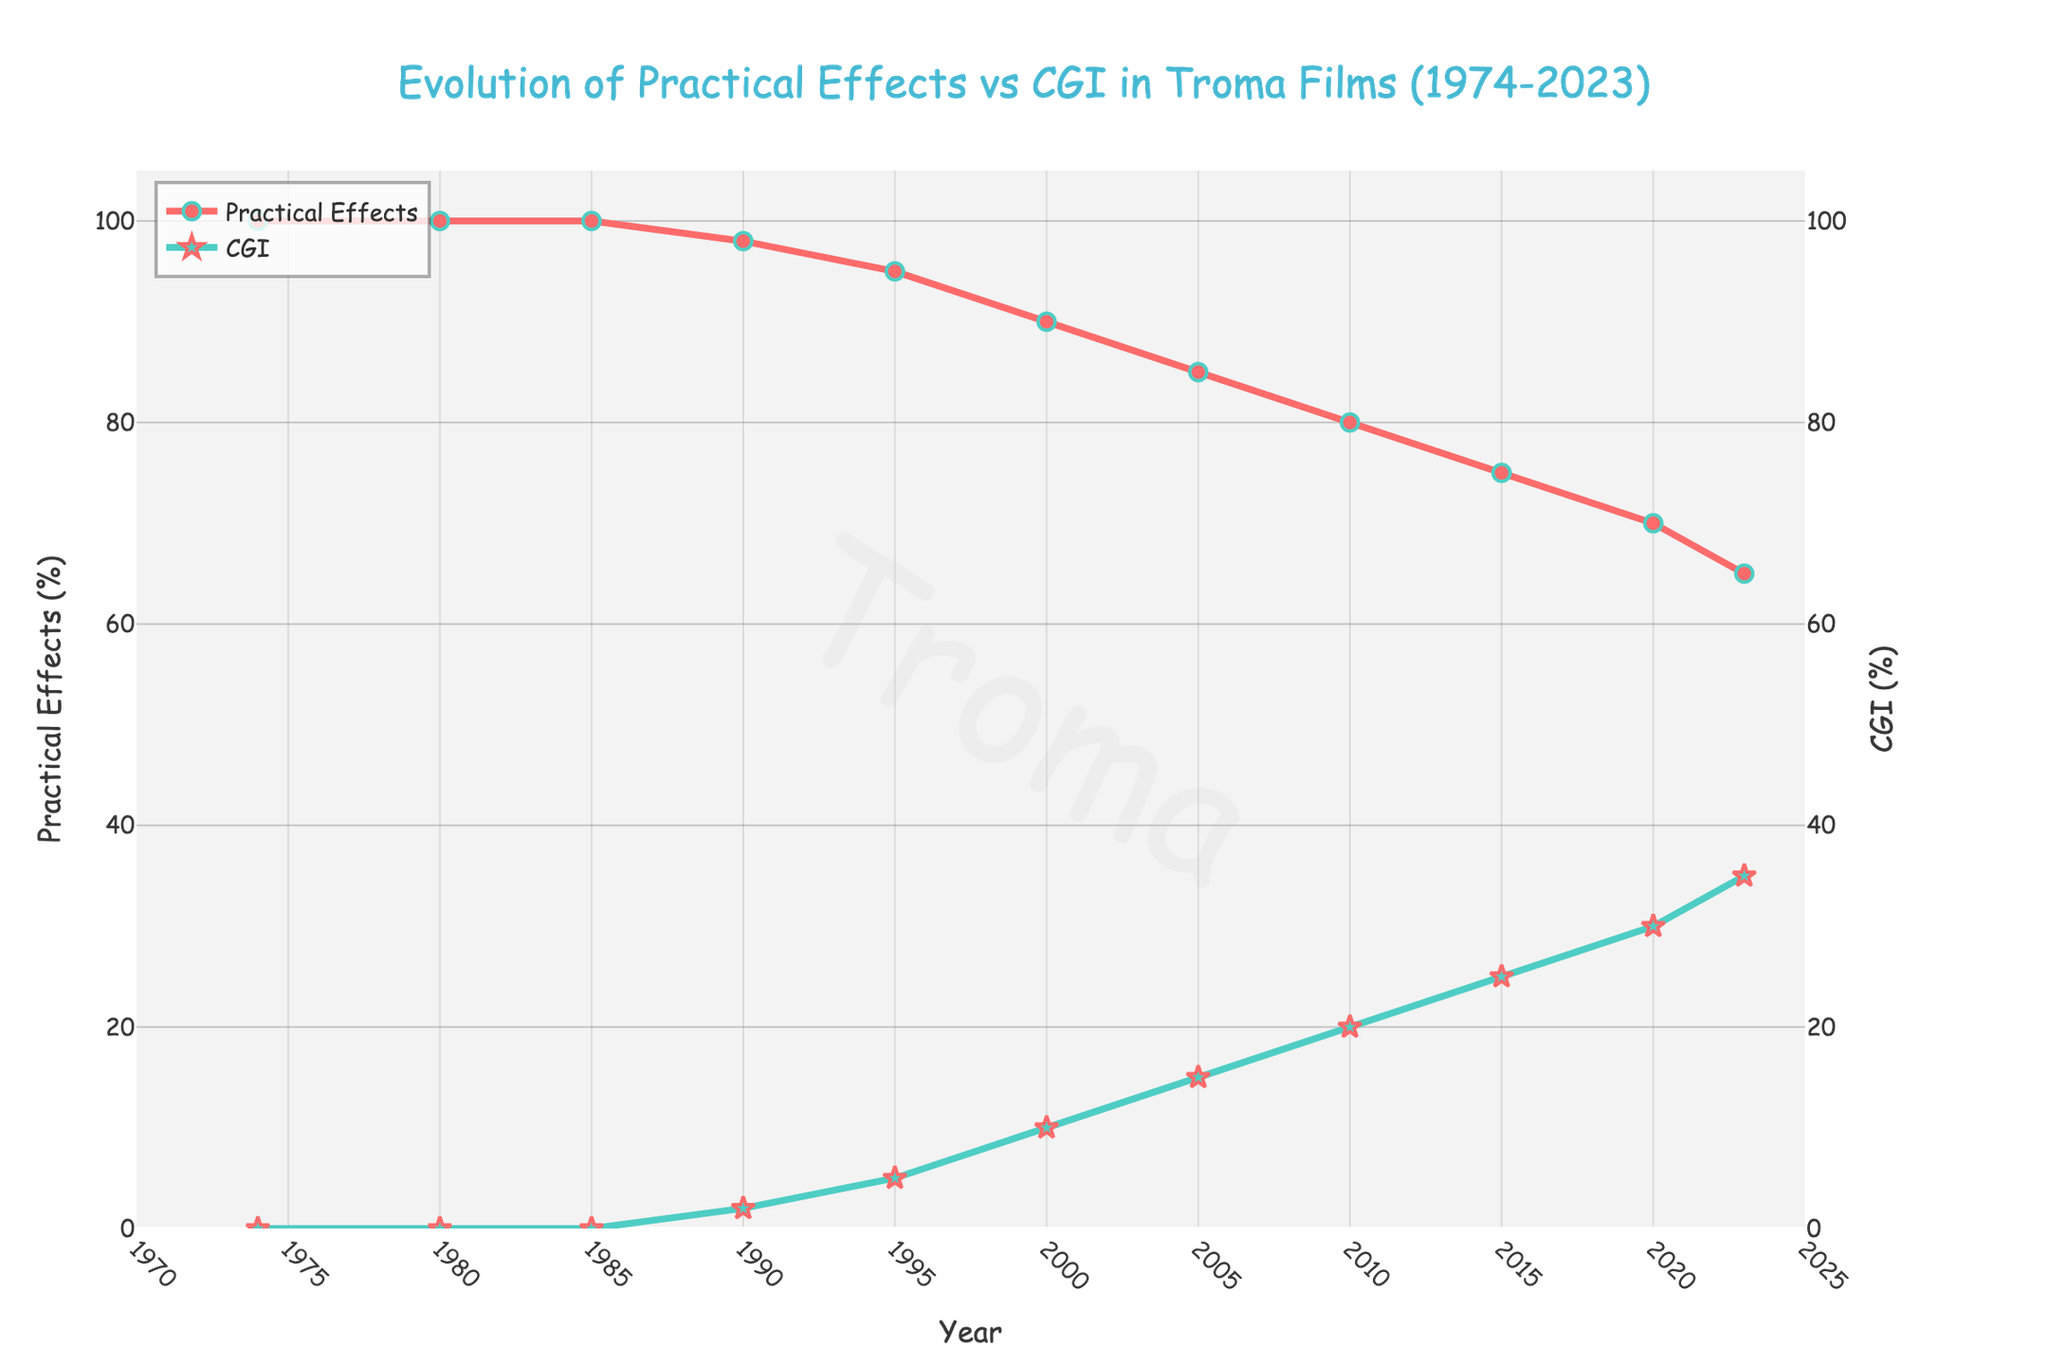What's the overall trend in the usage of practical effects from 1974 to 2023? By examining the line representing practical effects, you can see it starts at 100% in 1974 and gradually declines to 65% by 2023. The overall trend is a decrease in the usage of practical effects over time.
Answer: Decreasing In which year did the usage of CGI first appear in Troma films according to the chart? The CGI percentage is zero until 1990, where it first shows a value of 2%. Therefore, CGI usage first appears in 1990 according to the chart.
Answer: 1990 What is the difference in practical effects usage between 1980 and 2023? Practical effects in 1980 were at 100%. In 2023, they were at 65%. The difference in usage is 100% - 65% = 35%.
Answer: 35% By how much did the CGI usage increase from 2000 to 2023? In 2000, CGI usage is at 10%. By 2023, it increased to 35%. The increase in percentage is 35% - 10% = 25%.
Answer: 25% Compare the rates of change in practical effects and CGI between 2010 and 2020. Between 2010 and 2020, practical effects decreased from 80% to 70%, a change of 10%. CGI increased from 20% to 30%, also a change of 10%.
Answer: Same What is the percentage of practical effects compared to CGI in 2015? In 2015, practical effects are at 75%, and CGI is at 25%.
Answer: 75% vs 25% At what point did the difference between practical effects and CGI usage first equal 50%? In 2010, practical effects are at 80% and CGI is at 20%, so the difference is 80% - 20% = 60%. By 2015, practical effects are at 75% and CGI is at 25%, so the difference is 75% - 25% = 50%. Thus, this occurs in 2015.
Answer: 2015 What is the average percentage of practical effects from 1974 to 2023? Sum of practical effects percentages from 1974 to 2023: 100 + 100 + 100 + 98 + 95 + 90 + 85 + 80 + 75 + 70 + 65 = 958. There are 11 data points, so the average is 958 / 11 ≈ 87.09%.
Answer: 87.09% What visual characteristic distinguishes the practical effects line from the CGI line? The practical effects line is represented in red with circle markers, whereas the CGI line is shown in a greenish color with star markers.
Answer: Color and marker type Is there any year where the usage of practical effects and CGI is equal? By examining the chart, it is evident that at no point do the percentages of practical effects and CGI intersect or equal each other.
Answer: No 